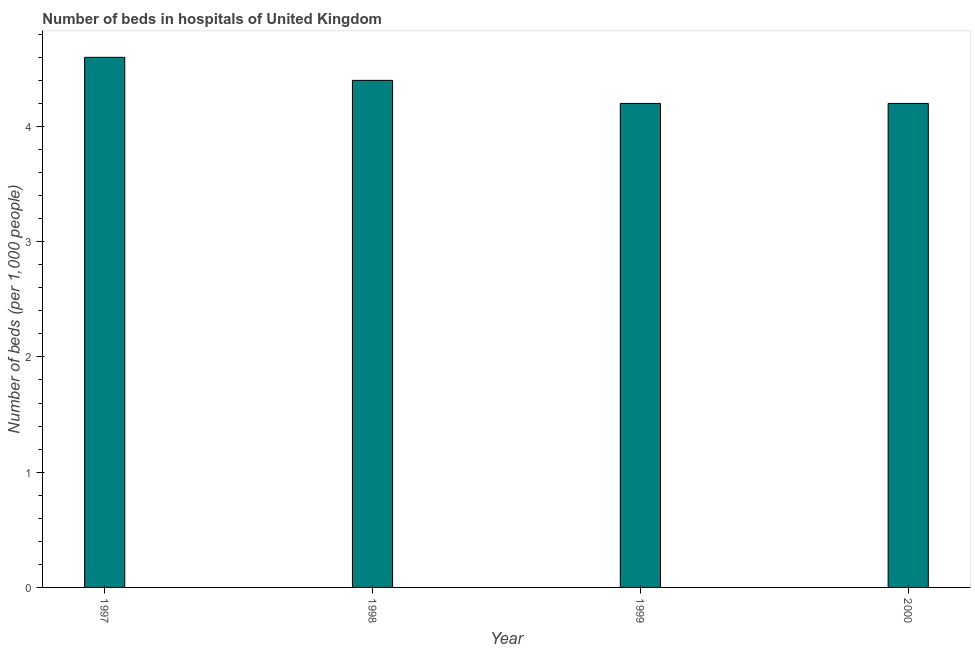Does the graph contain any zero values?
Your answer should be compact. No. Does the graph contain grids?
Offer a terse response. No. What is the title of the graph?
Keep it short and to the point. Number of beds in hospitals of United Kingdom. What is the label or title of the X-axis?
Offer a terse response. Year. What is the label or title of the Y-axis?
Offer a very short reply. Number of beds (per 1,0 people). What is the number of hospital beds in 1998?
Ensure brevity in your answer.  4.4. Across all years, what is the maximum number of hospital beds?
Give a very brief answer. 4.6. Across all years, what is the minimum number of hospital beds?
Provide a short and direct response. 4.2. In which year was the number of hospital beds minimum?
Your answer should be very brief. 1999. What is the sum of the number of hospital beds?
Give a very brief answer. 17.4. What is the average number of hospital beds per year?
Make the answer very short. 4.35. What is the median number of hospital beds?
Your answer should be very brief. 4.3. In how many years, is the number of hospital beds greater than 3.8 %?
Ensure brevity in your answer.  4. What is the ratio of the number of hospital beds in 1999 to that in 2000?
Make the answer very short. 1. What is the difference between the highest and the second highest number of hospital beds?
Your response must be concise. 0.2. Are all the bars in the graph horizontal?
Your answer should be compact. No. What is the difference between two consecutive major ticks on the Y-axis?
Offer a very short reply. 1. Are the values on the major ticks of Y-axis written in scientific E-notation?
Your answer should be very brief. No. What is the Number of beds (per 1,000 people) of 1997?
Your response must be concise. 4.6. What is the Number of beds (per 1,000 people) of 1998?
Your response must be concise. 4.4. What is the Number of beds (per 1,000 people) in 1999?
Make the answer very short. 4.2. What is the Number of beds (per 1,000 people) of 2000?
Provide a succinct answer. 4.2. What is the difference between the Number of beds (per 1,000 people) in 1997 and 1998?
Make the answer very short. 0.2. What is the difference between the Number of beds (per 1,000 people) in 1997 and 2000?
Offer a very short reply. 0.4. What is the difference between the Number of beds (per 1,000 people) in 1998 and 2000?
Make the answer very short. 0.2. What is the ratio of the Number of beds (per 1,000 people) in 1997 to that in 1998?
Offer a terse response. 1.04. What is the ratio of the Number of beds (per 1,000 people) in 1997 to that in 1999?
Offer a very short reply. 1.09. What is the ratio of the Number of beds (per 1,000 people) in 1997 to that in 2000?
Offer a terse response. 1.09. What is the ratio of the Number of beds (per 1,000 people) in 1998 to that in 1999?
Your response must be concise. 1.05. What is the ratio of the Number of beds (per 1,000 people) in 1998 to that in 2000?
Offer a very short reply. 1.05. What is the ratio of the Number of beds (per 1,000 people) in 1999 to that in 2000?
Your answer should be very brief. 1. 